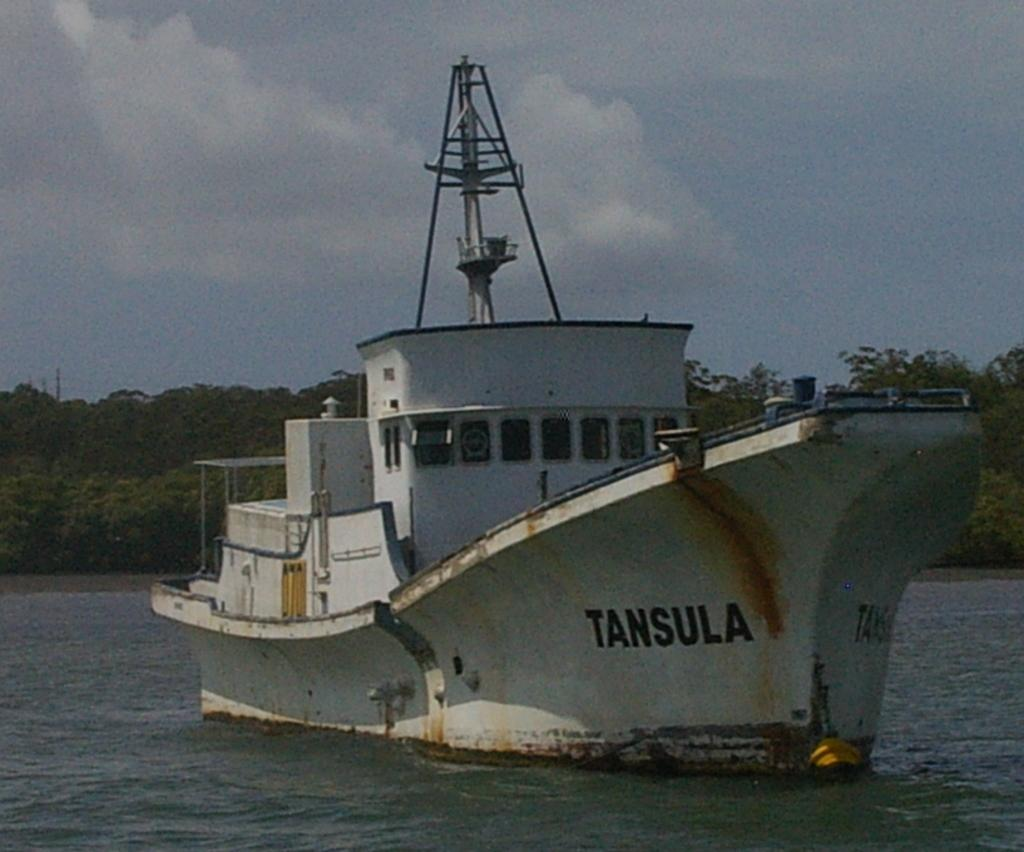What is the main subject of the image? The main subject of the image is a ship. Where is the ship located in the image? The ship is on the water. What can be seen on the ship? There is text on the ship. What type of natural environment is visible in the image? Trees and the sky are visible in the image. What is the condition of the sky in the image? The sky is visible with clouds in the image. What is present at the bottom of the image? Water is present at the bottom of the image. How many women are holding quivers on the ship in the image? There are no women or quivers present in the image. What type of friction is occurring between the ship and the water in the image? The image does not provide information about the friction between the ship and the water. 